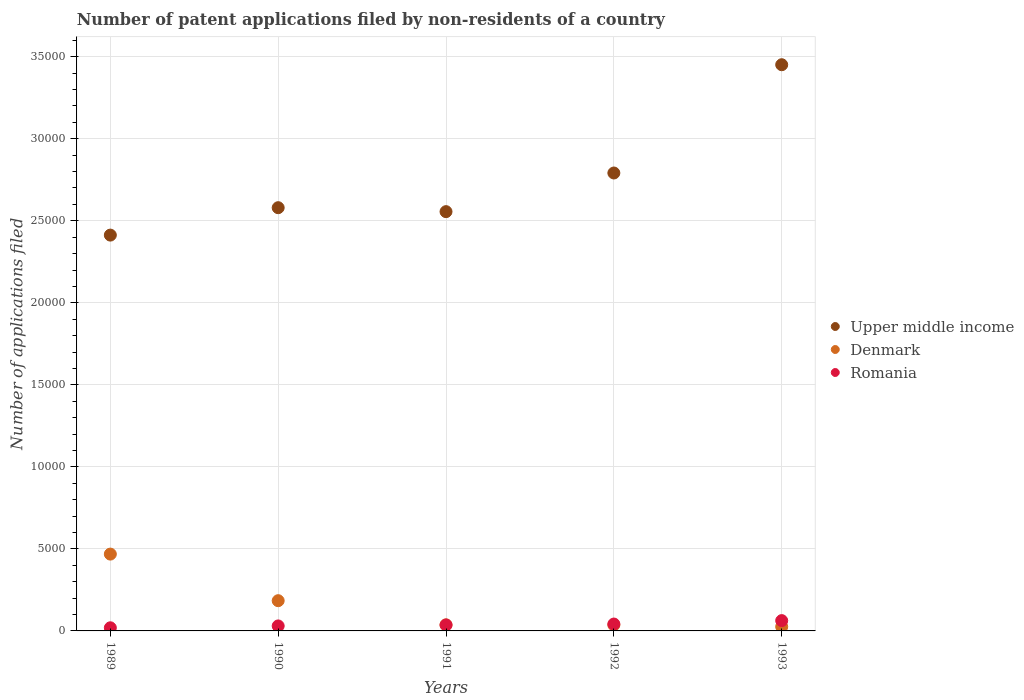What is the number of applications filed in Denmark in 1993?
Your answer should be compact. 254. Across all years, what is the maximum number of applications filed in Denmark?
Your response must be concise. 4683. Across all years, what is the minimum number of applications filed in Romania?
Provide a short and direct response. 191. In which year was the number of applications filed in Upper middle income maximum?
Provide a succinct answer. 1993. In which year was the number of applications filed in Upper middle income minimum?
Make the answer very short. 1989. What is the total number of applications filed in Denmark in the graph?
Ensure brevity in your answer.  7511. What is the difference between the number of applications filed in Upper middle income in 1990 and that in 1993?
Your answer should be compact. -8715. What is the difference between the number of applications filed in Denmark in 1993 and the number of applications filed in Romania in 1991?
Your response must be concise. -107. What is the average number of applications filed in Romania per year?
Keep it short and to the point. 380.8. In the year 1991, what is the difference between the number of applications filed in Upper middle income and number of applications filed in Romania?
Give a very brief answer. 2.52e+04. What is the ratio of the number of applications filed in Upper middle income in 1990 to that in 1992?
Make the answer very short. 0.92. Is the number of applications filed in Denmark in 1990 less than that in 1993?
Provide a succinct answer. No. What is the difference between the highest and the second highest number of applications filed in Denmark?
Give a very brief answer. 2840. What is the difference between the highest and the lowest number of applications filed in Denmark?
Give a very brief answer. 4429. In how many years, is the number of applications filed in Upper middle income greater than the average number of applications filed in Upper middle income taken over all years?
Keep it short and to the point. 2. Is the sum of the number of applications filed in Upper middle income in 1990 and 1992 greater than the maximum number of applications filed in Romania across all years?
Give a very brief answer. Yes. How many dotlines are there?
Offer a very short reply. 3. What is the difference between two consecutive major ticks on the Y-axis?
Your answer should be very brief. 5000. Are the values on the major ticks of Y-axis written in scientific E-notation?
Your answer should be compact. No. How are the legend labels stacked?
Your answer should be very brief. Vertical. What is the title of the graph?
Make the answer very short. Number of patent applications filed by non-residents of a country. What is the label or title of the X-axis?
Ensure brevity in your answer.  Years. What is the label or title of the Y-axis?
Make the answer very short. Number of applications filed. What is the Number of applications filed in Upper middle income in 1989?
Ensure brevity in your answer.  2.41e+04. What is the Number of applications filed in Denmark in 1989?
Offer a terse response. 4683. What is the Number of applications filed of Romania in 1989?
Your response must be concise. 191. What is the Number of applications filed of Upper middle income in 1990?
Your response must be concise. 2.58e+04. What is the Number of applications filed in Denmark in 1990?
Ensure brevity in your answer.  1843. What is the Number of applications filed in Romania in 1990?
Keep it short and to the point. 304. What is the Number of applications filed in Upper middle income in 1991?
Your response must be concise. 2.56e+04. What is the Number of applications filed of Denmark in 1991?
Provide a succinct answer. 370. What is the Number of applications filed in Romania in 1991?
Your response must be concise. 361. What is the Number of applications filed in Upper middle income in 1992?
Your answer should be very brief. 2.79e+04. What is the Number of applications filed in Denmark in 1992?
Your answer should be compact. 361. What is the Number of applications filed of Romania in 1992?
Give a very brief answer. 420. What is the Number of applications filed in Upper middle income in 1993?
Make the answer very short. 3.45e+04. What is the Number of applications filed in Denmark in 1993?
Provide a succinct answer. 254. What is the Number of applications filed in Romania in 1993?
Make the answer very short. 628. Across all years, what is the maximum Number of applications filed of Upper middle income?
Provide a short and direct response. 3.45e+04. Across all years, what is the maximum Number of applications filed in Denmark?
Keep it short and to the point. 4683. Across all years, what is the maximum Number of applications filed of Romania?
Keep it short and to the point. 628. Across all years, what is the minimum Number of applications filed in Upper middle income?
Provide a succinct answer. 2.41e+04. Across all years, what is the minimum Number of applications filed of Denmark?
Your answer should be very brief. 254. Across all years, what is the minimum Number of applications filed in Romania?
Offer a very short reply. 191. What is the total Number of applications filed of Upper middle income in the graph?
Your answer should be very brief. 1.38e+05. What is the total Number of applications filed in Denmark in the graph?
Your answer should be compact. 7511. What is the total Number of applications filed of Romania in the graph?
Make the answer very short. 1904. What is the difference between the Number of applications filed in Upper middle income in 1989 and that in 1990?
Make the answer very short. -1671. What is the difference between the Number of applications filed of Denmark in 1989 and that in 1990?
Offer a terse response. 2840. What is the difference between the Number of applications filed of Romania in 1989 and that in 1990?
Give a very brief answer. -113. What is the difference between the Number of applications filed of Upper middle income in 1989 and that in 1991?
Make the answer very short. -1430. What is the difference between the Number of applications filed of Denmark in 1989 and that in 1991?
Ensure brevity in your answer.  4313. What is the difference between the Number of applications filed of Romania in 1989 and that in 1991?
Keep it short and to the point. -170. What is the difference between the Number of applications filed of Upper middle income in 1989 and that in 1992?
Your response must be concise. -3786. What is the difference between the Number of applications filed in Denmark in 1989 and that in 1992?
Provide a succinct answer. 4322. What is the difference between the Number of applications filed in Romania in 1989 and that in 1992?
Keep it short and to the point. -229. What is the difference between the Number of applications filed in Upper middle income in 1989 and that in 1993?
Ensure brevity in your answer.  -1.04e+04. What is the difference between the Number of applications filed of Denmark in 1989 and that in 1993?
Provide a succinct answer. 4429. What is the difference between the Number of applications filed of Romania in 1989 and that in 1993?
Make the answer very short. -437. What is the difference between the Number of applications filed of Upper middle income in 1990 and that in 1991?
Offer a terse response. 241. What is the difference between the Number of applications filed in Denmark in 1990 and that in 1991?
Keep it short and to the point. 1473. What is the difference between the Number of applications filed of Romania in 1990 and that in 1991?
Offer a very short reply. -57. What is the difference between the Number of applications filed in Upper middle income in 1990 and that in 1992?
Your response must be concise. -2115. What is the difference between the Number of applications filed of Denmark in 1990 and that in 1992?
Offer a terse response. 1482. What is the difference between the Number of applications filed in Romania in 1990 and that in 1992?
Offer a terse response. -116. What is the difference between the Number of applications filed of Upper middle income in 1990 and that in 1993?
Your response must be concise. -8715. What is the difference between the Number of applications filed of Denmark in 1990 and that in 1993?
Provide a short and direct response. 1589. What is the difference between the Number of applications filed in Romania in 1990 and that in 1993?
Provide a short and direct response. -324. What is the difference between the Number of applications filed in Upper middle income in 1991 and that in 1992?
Your answer should be very brief. -2356. What is the difference between the Number of applications filed in Denmark in 1991 and that in 1992?
Your answer should be compact. 9. What is the difference between the Number of applications filed of Romania in 1991 and that in 1992?
Provide a short and direct response. -59. What is the difference between the Number of applications filed in Upper middle income in 1991 and that in 1993?
Your answer should be very brief. -8956. What is the difference between the Number of applications filed of Denmark in 1991 and that in 1993?
Ensure brevity in your answer.  116. What is the difference between the Number of applications filed in Romania in 1991 and that in 1993?
Ensure brevity in your answer.  -267. What is the difference between the Number of applications filed in Upper middle income in 1992 and that in 1993?
Provide a short and direct response. -6600. What is the difference between the Number of applications filed of Denmark in 1992 and that in 1993?
Your response must be concise. 107. What is the difference between the Number of applications filed of Romania in 1992 and that in 1993?
Your answer should be compact. -208. What is the difference between the Number of applications filed in Upper middle income in 1989 and the Number of applications filed in Denmark in 1990?
Make the answer very short. 2.23e+04. What is the difference between the Number of applications filed of Upper middle income in 1989 and the Number of applications filed of Romania in 1990?
Ensure brevity in your answer.  2.38e+04. What is the difference between the Number of applications filed in Denmark in 1989 and the Number of applications filed in Romania in 1990?
Provide a succinct answer. 4379. What is the difference between the Number of applications filed of Upper middle income in 1989 and the Number of applications filed of Denmark in 1991?
Offer a terse response. 2.38e+04. What is the difference between the Number of applications filed in Upper middle income in 1989 and the Number of applications filed in Romania in 1991?
Your answer should be very brief. 2.38e+04. What is the difference between the Number of applications filed of Denmark in 1989 and the Number of applications filed of Romania in 1991?
Your answer should be compact. 4322. What is the difference between the Number of applications filed in Upper middle income in 1989 and the Number of applications filed in Denmark in 1992?
Keep it short and to the point. 2.38e+04. What is the difference between the Number of applications filed in Upper middle income in 1989 and the Number of applications filed in Romania in 1992?
Offer a very short reply. 2.37e+04. What is the difference between the Number of applications filed in Denmark in 1989 and the Number of applications filed in Romania in 1992?
Provide a short and direct response. 4263. What is the difference between the Number of applications filed of Upper middle income in 1989 and the Number of applications filed of Denmark in 1993?
Keep it short and to the point. 2.39e+04. What is the difference between the Number of applications filed in Upper middle income in 1989 and the Number of applications filed in Romania in 1993?
Your response must be concise. 2.35e+04. What is the difference between the Number of applications filed in Denmark in 1989 and the Number of applications filed in Romania in 1993?
Your response must be concise. 4055. What is the difference between the Number of applications filed of Upper middle income in 1990 and the Number of applications filed of Denmark in 1991?
Provide a succinct answer. 2.54e+04. What is the difference between the Number of applications filed of Upper middle income in 1990 and the Number of applications filed of Romania in 1991?
Give a very brief answer. 2.54e+04. What is the difference between the Number of applications filed in Denmark in 1990 and the Number of applications filed in Romania in 1991?
Provide a succinct answer. 1482. What is the difference between the Number of applications filed in Upper middle income in 1990 and the Number of applications filed in Denmark in 1992?
Your answer should be compact. 2.54e+04. What is the difference between the Number of applications filed of Upper middle income in 1990 and the Number of applications filed of Romania in 1992?
Make the answer very short. 2.54e+04. What is the difference between the Number of applications filed of Denmark in 1990 and the Number of applications filed of Romania in 1992?
Ensure brevity in your answer.  1423. What is the difference between the Number of applications filed of Upper middle income in 1990 and the Number of applications filed of Denmark in 1993?
Make the answer very short. 2.55e+04. What is the difference between the Number of applications filed in Upper middle income in 1990 and the Number of applications filed in Romania in 1993?
Make the answer very short. 2.52e+04. What is the difference between the Number of applications filed in Denmark in 1990 and the Number of applications filed in Romania in 1993?
Give a very brief answer. 1215. What is the difference between the Number of applications filed of Upper middle income in 1991 and the Number of applications filed of Denmark in 1992?
Provide a succinct answer. 2.52e+04. What is the difference between the Number of applications filed of Upper middle income in 1991 and the Number of applications filed of Romania in 1992?
Your answer should be compact. 2.51e+04. What is the difference between the Number of applications filed in Upper middle income in 1991 and the Number of applications filed in Denmark in 1993?
Offer a terse response. 2.53e+04. What is the difference between the Number of applications filed of Upper middle income in 1991 and the Number of applications filed of Romania in 1993?
Your answer should be very brief. 2.49e+04. What is the difference between the Number of applications filed of Denmark in 1991 and the Number of applications filed of Romania in 1993?
Keep it short and to the point. -258. What is the difference between the Number of applications filed in Upper middle income in 1992 and the Number of applications filed in Denmark in 1993?
Your answer should be very brief. 2.77e+04. What is the difference between the Number of applications filed in Upper middle income in 1992 and the Number of applications filed in Romania in 1993?
Give a very brief answer. 2.73e+04. What is the difference between the Number of applications filed in Denmark in 1992 and the Number of applications filed in Romania in 1993?
Your answer should be very brief. -267. What is the average Number of applications filed of Upper middle income per year?
Your answer should be very brief. 2.76e+04. What is the average Number of applications filed of Denmark per year?
Offer a terse response. 1502.2. What is the average Number of applications filed of Romania per year?
Give a very brief answer. 380.8. In the year 1989, what is the difference between the Number of applications filed in Upper middle income and Number of applications filed in Denmark?
Keep it short and to the point. 1.94e+04. In the year 1989, what is the difference between the Number of applications filed in Upper middle income and Number of applications filed in Romania?
Keep it short and to the point. 2.39e+04. In the year 1989, what is the difference between the Number of applications filed in Denmark and Number of applications filed in Romania?
Offer a very short reply. 4492. In the year 1990, what is the difference between the Number of applications filed of Upper middle income and Number of applications filed of Denmark?
Provide a succinct answer. 2.40e+04. In the year 1990, what is the difference between the Number of applications filed of Upper middle income and Number of applications filed of Romania?
Ensure brevity in your answer.  2.55e+04. In the year 1990, what is the difference between the Number of applications filed in Denmark and Number of applications filed in Romania?
Ensure brevity in your answer.  1539. In the year 1991, what is the difference between the Number of applications filed of Upper middle income and Number of applications filed of Denmark?
Provide a short and direct response. 2.52e+04. In the year 1991, what is the difference between the Number of applications filed in Upper middle income and Number of applications filed in Romania?
Keep it short and to the point. 2.52e+04. In the year 1992, what is the difference between the Number of applications filed of Upper middle income and Number of applications filed of Denmark?
Make the answer very short. 2.76e+04. In the year 1992, what is the difference between the Number of applications filed of Upper middle income and Number of applications filed of Romania?
Keep it short and to the point. 2.75e+04. In the year 1992, what is the difference between the Number of applications filed in Denmark and Number of applications filed in Romania?
Your answer should be compact. -59. In the year 1993, what is the difference between the Number of applications filed in Upper middle income and Number of applications filed in Denmark?
Offer a terse response. 3.43e+04. In the year 1993, what is the difference between the Number of applications filed of Upper middle income and Number of applications filed of Romania?
Provide a succinct answer. 3.39e+04. In the year 1993, what is the difference between the Number of applications filed in Denmark and Number of applications filed in Romania?
Ensure brevity in your answer.  -374. What is the ratio of the Number of applications filed of Upper middle income in 1989 to that in 1990?
Provide a short and direct response. 0.94. What is the ratio of the Number of applications filed in Denmark in 1989 to that in 1990?
Offer a very short reply. 2.54. What is the ratio of the Number of applications filed of Romania in 1989 to that in 1990?
Provide a short and direct response. 0.63. What is the ratio of the Number of applications filed of Upper middle income in 1989 to that in 1991?
Your response must be concise. 0.94. What is the ratio of the Number of applications filed of Denmark in 1989 to that in 1991?
Your answer should be compact. 12.66. What is the ratio of the Number of applications filed in Romania in 1989 to that in 1991?
Provide a short and direct response. 0.53. What is the ratio of the Number of applications filed in Upper middle income in 1989 to that in 1992?
Give a very brief answer. 0.86. What is the ratio of the Number of applications filed in Denmark in 1989 to that in 1992?
Give a very brief answer. 12.97. What is the ratio of the Number of applications filed in Romania in 1989 to that in 1992?
Your response must be concise. 0.45. What is the ratio of the Number of applications filed in Upper middle income in 1989 to that in 1993?
Your answer should be compact. 0.7. What is the ratio of the Number of applications filed in Denmark in 1989 to that in 1993?
Make the answer very short. 18.44. What is the ratio of the Number of applications filed in Romania in 1989 to that in 1993?
Give a very brief answer. 0.3. What is the ratio of the Number of applications filed in Upper middle income in 1990 to that in 1991?
Give a very brief answer. 1.01. What is the ratio of the Number of applications filed in Denmark in 1990 to that in 1991?
Your answer should be compact. 4.98. What is the ratio of the Number of applications filed of Romania in 1990 to that in 1991?
Ensure brevity in your answer.  0.84. What is the ratio of the Number of applications filed of Upper middle income in 1990 to that in 1992?
Offer a terse response. 0.92. What is the ratio of the Number of applications filed of Denmark in 1990 to that in 1992?
Make the answer very short. 5.11. What is the ratio of the Number of applications filed of Romania in 1990 to that in 1992?
Offer a terse response. 0.72. What is the ratio of the Number of applications filed in Upper middle income in 1990 to that in 1993?
Keep it short and to the point. 0.75. What is the ratio of the Number of applications filed in Denmark in 1990 to that in 1993?
Your answer should be compact. 7.26. What is the ratio of the Number of applications filed of Romania in 1990 to that in 1993?
Ensure brevity in your answer.  0.48. What is the ratio of the Number of applications filed in Upper middle income in 1991 to that in 1992?
Offer a terse response. 0.92. What is the ratio of the Number of applications filed in Denmark in 1991 to that in 1992?
Provide a short and direct response. 1.02. What is the ratio of the Number of applications filed in Romania in 1991 to that in 1992?
Keep it short and to the point. 0.86. What is the ratio of the Number of applications filed in Upper middle income in 1991 to that in 1993?
Keep it short and to the point. 0.74. What is the ratio of the Number of applications filed in Denmark in 1991 to that in 1993?
Provide a short and direct response. 1.46. What is the ratio of the Number of applications filed in Romania in 1991 to that in 1993?
Give a very brief answer. 0.57. What is the ratio of the Number of applications filed in Upper middle income in 1992 to that in 1993?
Your answer should be compact. 0.81. What is the ratio of the Number of applications filed of Denmark in 1992 to that in 1993?
Offer a terse response. 1.42. What is the ratio of the Number of applications filed in Romania in 1992 to that in 1993?
Give a very brief answer. 0.67. What is the difference between the highest and the second highest Number of applications filed in Upper middle income?
Keep it short and to the point. 6600. What is the difference between the highest and the second highest Number of applications filed in Denmark?
Your answer should be compact. 2840. What is the difference between the highest and the second highest Number of applications filed of Romania?
Your answer should be compact. 208. What is the difference between the highest and the lowest Number of applications filed in Upper middle income?
Your response must be concise. 1.04e+04. What is the difference between the highest and the lowest Number of applications filed in Denmark?
Give a very brief answer. 4429. What is the difference between the highest and the lowest Number of applications filed of Romania?
Offer a terse response. 437. 